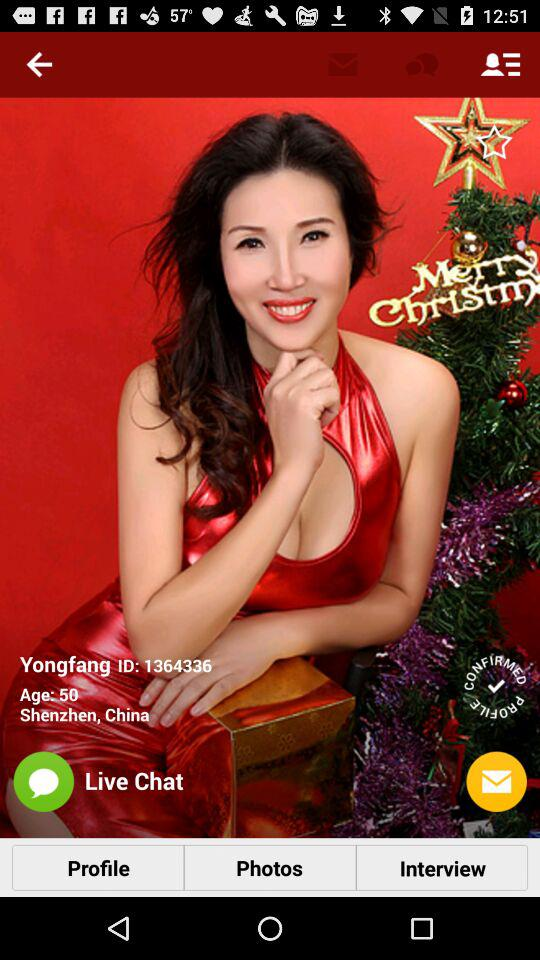What is the age? The age is 50 years. 